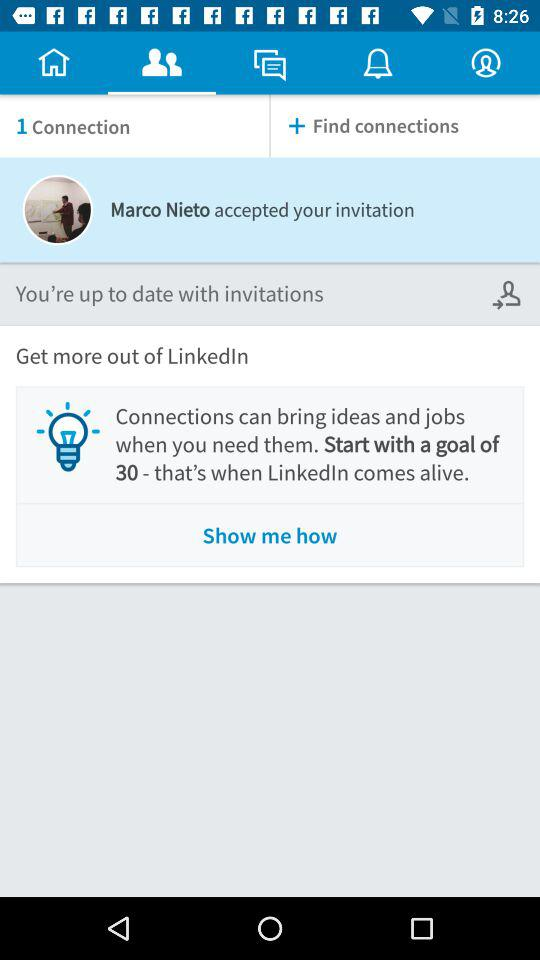How many more connections do I need to reach my goal?
Answer the question using a single word or phrase. 29 